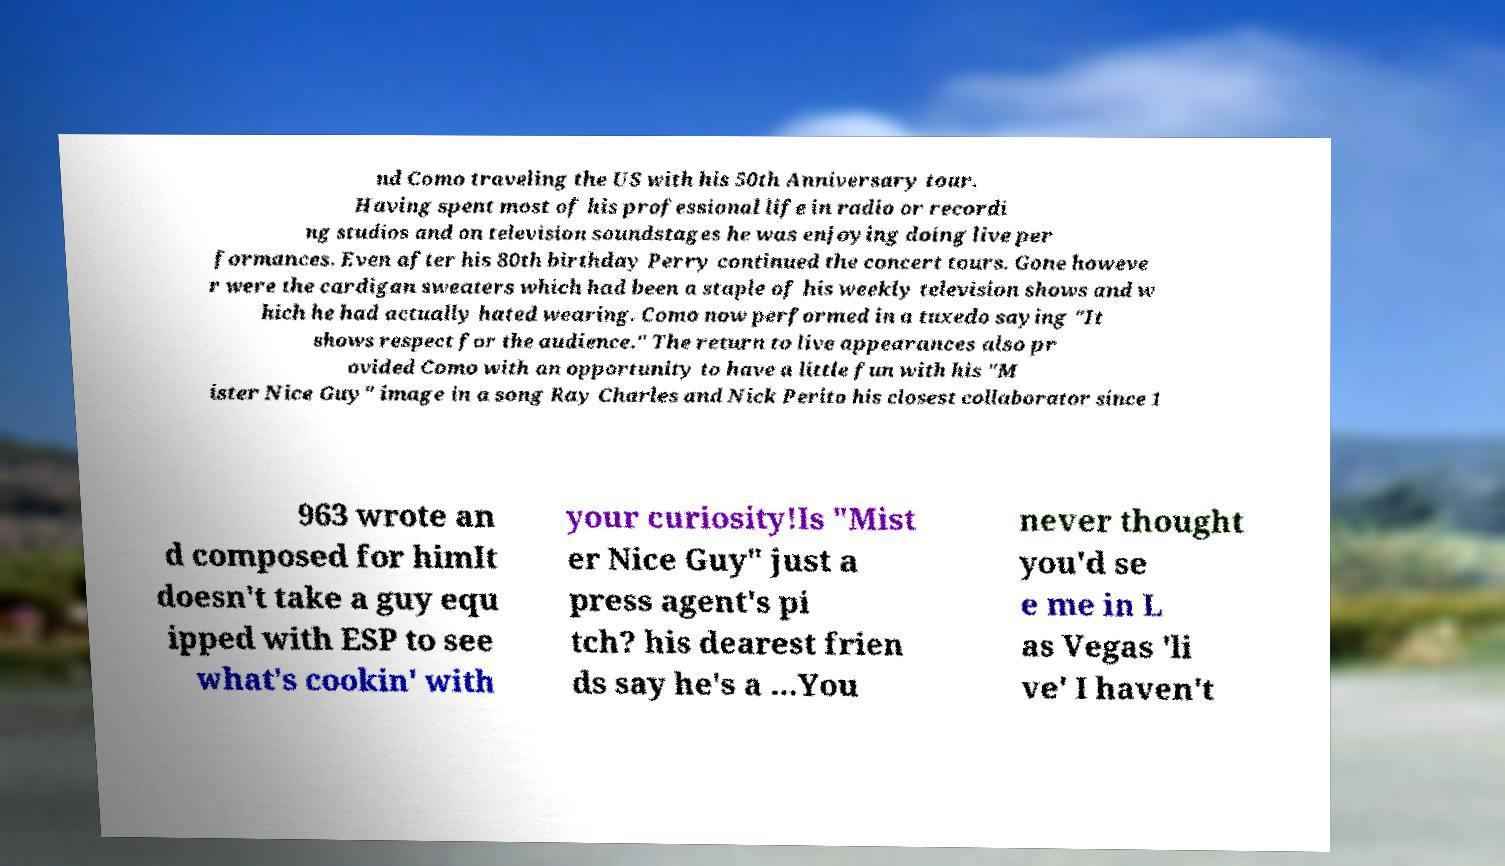I need the written content from this picture converted into text. Can you do that? nd Como traveling the US with his 50th Anniversary tour. Having spent most of his professional life in radio or recordi ng studios and on television soundstages he was enjoying doing live per formances. Even after his 80th birthday Perry continued the concert tours. Gone howeve r were the cardigan sweaters which had been a staple of his weekly television shows and w hich he had actually hated wearing. Como now performed in a tuxedo saying "It shows respect for the audience." The return to live appearances also pr ovided Como with an opportunity to have a little fun with his "M ister Nice Guy" image in a song Ray Charles and Nick Perito his closest collaborator since 1 963 wrote an d composed for himIt doesn't take a guy equ ipped with ESP to see what's cookin' with your curiosity!Is "Mist er Nice Guy" just a press agent's pi tch? his dearest frien ds say he's a ...You never thought you'd se e me in L as Vegas 'li ve' I haven't 